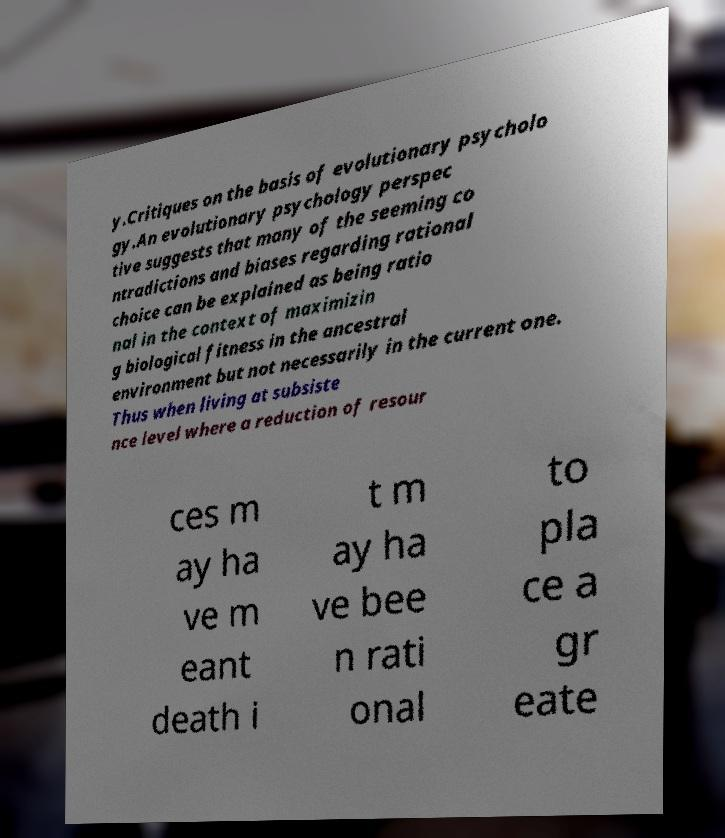I need the written content from this picture converted into text. Can you do that? y.Critiques on the basis of evolutionary psycholo gy.An evolutionary psychology perspec tive suggests that many of the seeming co ntradictions and biases regarding rational choice can be explained as being ratio nal in the context of maximizin g biological fitness in the ancestral environment but not necessarily in the current one. Thus when living at subsiste nce level where a reduction of resour ces m ay ha ve m eant death i t m ay ha ve bee n rati onal to pla ce a gr eate 